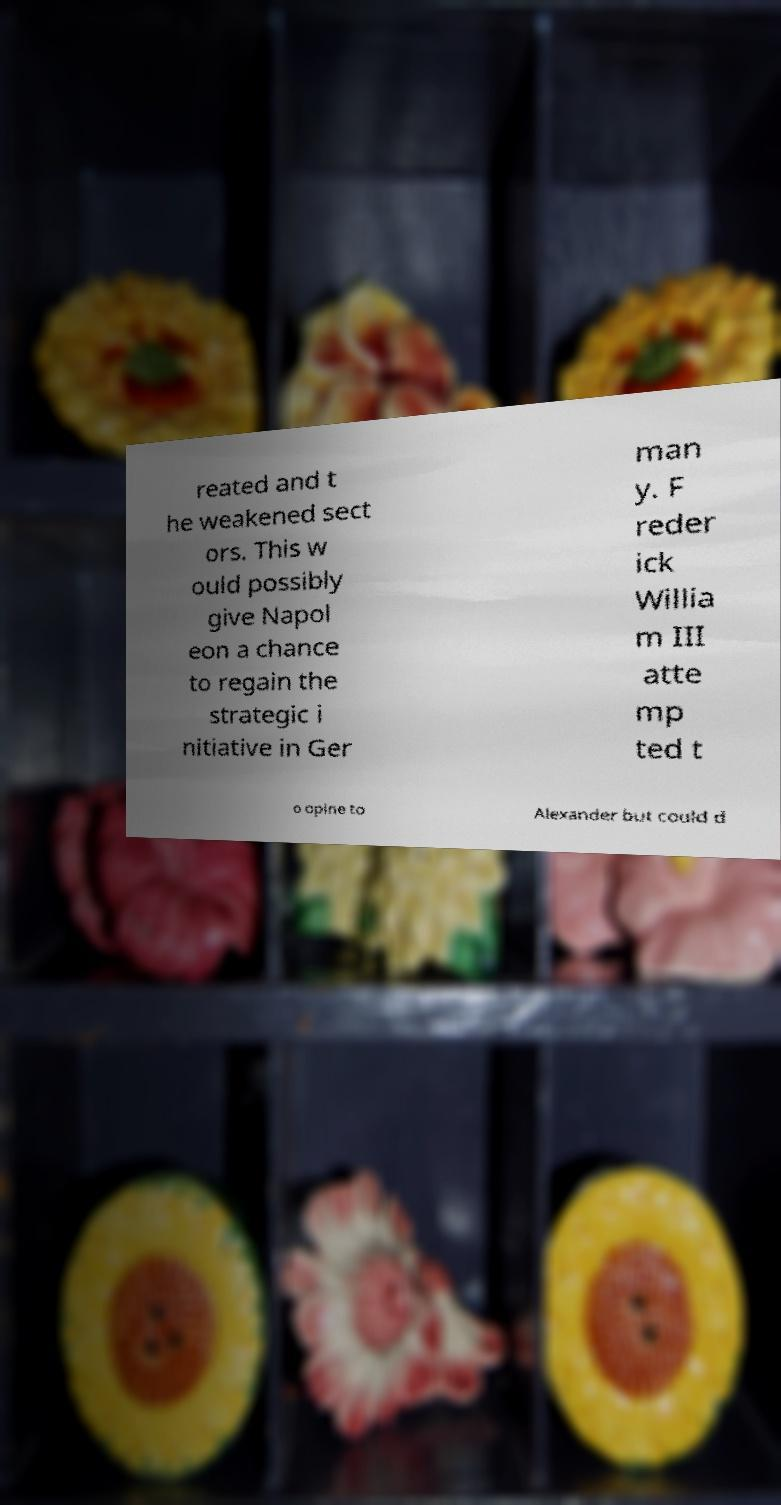Please identify and transcribe the text found in this image. reated and t he weakened sect ors. This w ould possibly give Napol eon a chance to regain the strategic i nitiative in Ger man y. F reder ick Willia m III atte mp ted t o opine to Alexander but could d 